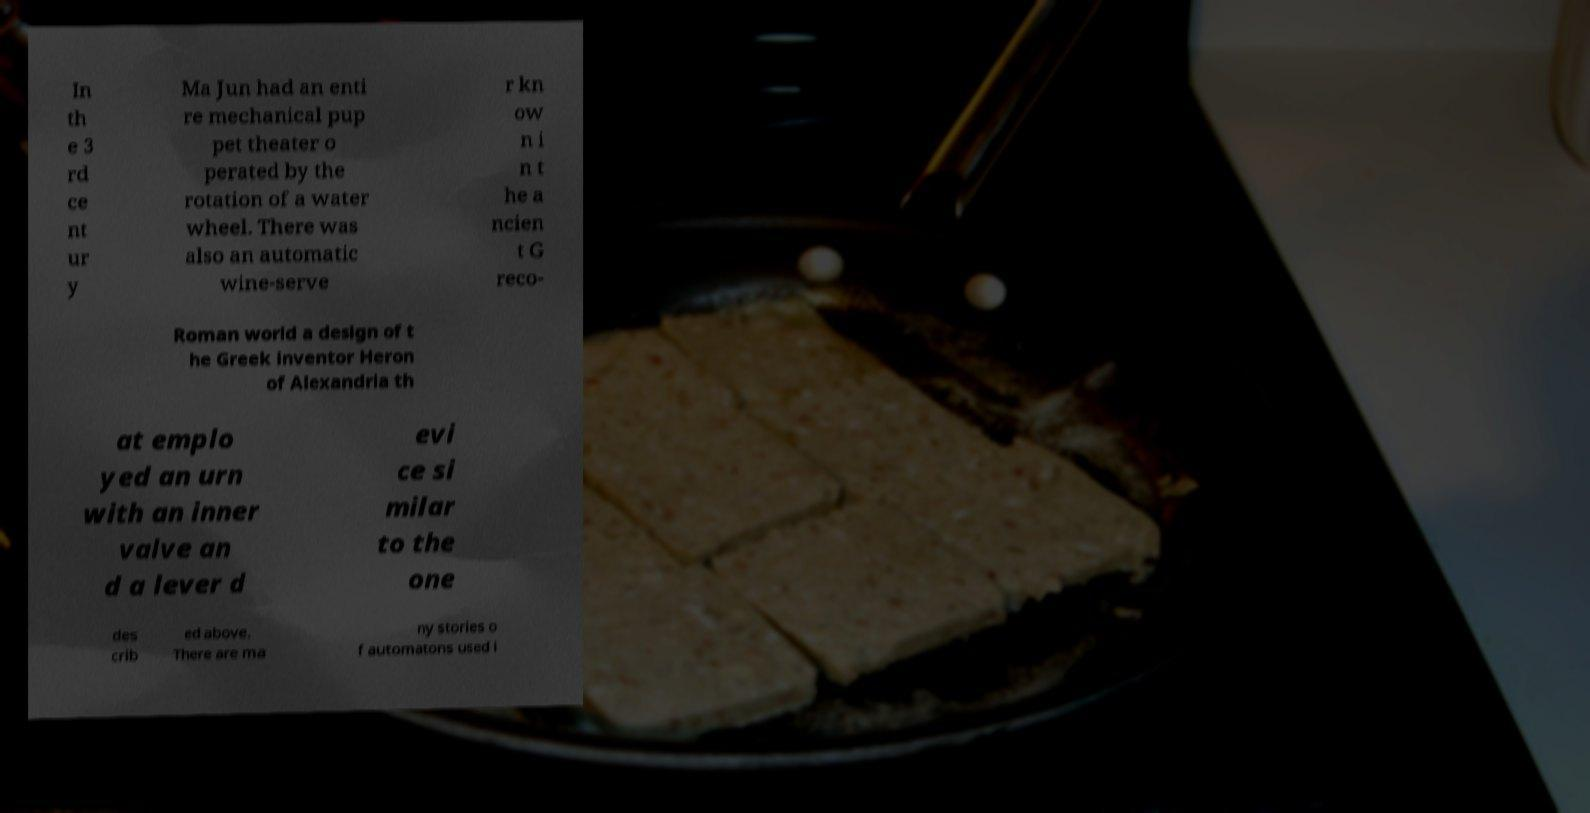What messages or text are displayed in this image? I need them in a readable, typed format. In th e 3 rd ce nt ur y Ma Jun had an enti re mechanical pup pet theater o perated by the rotation of a water wheel. There was also an automatic wine-serve r kn ow n i n t he a ncien t G reco- Roman world a design of t he Greek inventor Heron of Alexandria th at emplo yed an urn with an inner valve an d a lever d evi ce si milar to the one des crib ed above. There are ma ny stories o f automatons used i 